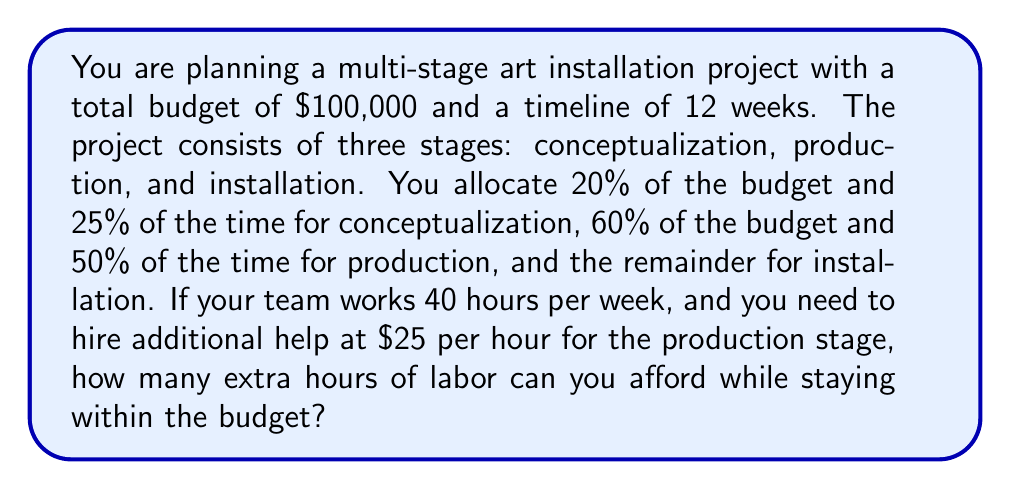Could you help me with this problem? Let's break this down step-by-step:

1. Calculate the budget for each stage:
   Conceptualization: $100,000 * 20% = $20,000
   Production: $100,000 * 60% = $60,000
   Installation: $100,000 * 20% = $20,000 (remainder)

2. Calculate the time allocated for each stage:
   Conceptualization: 12 weeks * 25% = 3 weeks
   Production: 12 weeks * 50% = 6 weeks
   Installation: 12 weeks * 25% = 3 weeks (remainder)

3. Calculate the total hours available for the production stage:
   6 weeks * 40 hours/week = 240 hours

4. Determine the budget available for additional labor in the production stage:
   We need to find out how much of the $60,000 production budget is available after accounting for other expenses. Let's assume that 70% of the production budget is allocated for materials and equipment, leaving 30% for labor.
   
   Available for labor: $60,000 * 30% = $18,000

5. Calculate the number of extra hours that can be hired:
   Let $x$ be the number of extra hours
   $$18,000 = 25x$$
   $$x = \frac{18,000}{25} = 720$$

Therefore, you can afford to hire an additional 720 hours of labor for the production stage while staying within the budget.
Answer: 720 hours 